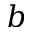<formula> <loc_0><loc_0><loc_500><loc_500>b</formula> 